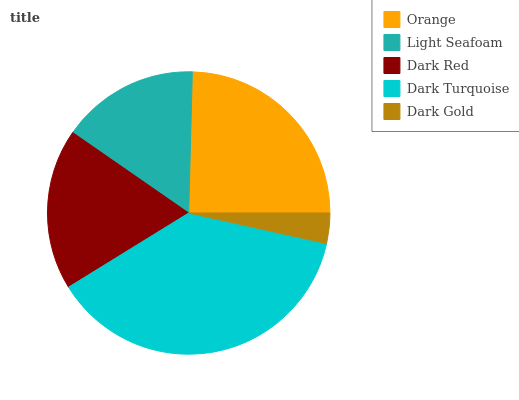Is Dark Gold the minimum?
Answer yes or no. Yes. Is Dark Turquoise the maximum?
Answer yes or no. Yes. Is Light Seafoam the minimum?
Answer yes or no. No. Is Light Seafoam the maximum?
Answer yes or no. No. Is Orange greater than Light Seafoam?
Answer yes or no. Yes. Is Light Seafoam less than Orange?
Answer yes or no. Yes. Is Light Seafoam greater than Orange?
Answer yes or no. No. Is Orange less than Light Seafoam?
Answer yes or no. No. Is Dark Red the high median?
Answer yes or no. Yes. Is Dark Red the low median?
Answer yes or no. Yes. Is Dark Turquoise the high median?
Answer yes or no. No. Is Dark Gold the low median?
Answer yes or no. No. 